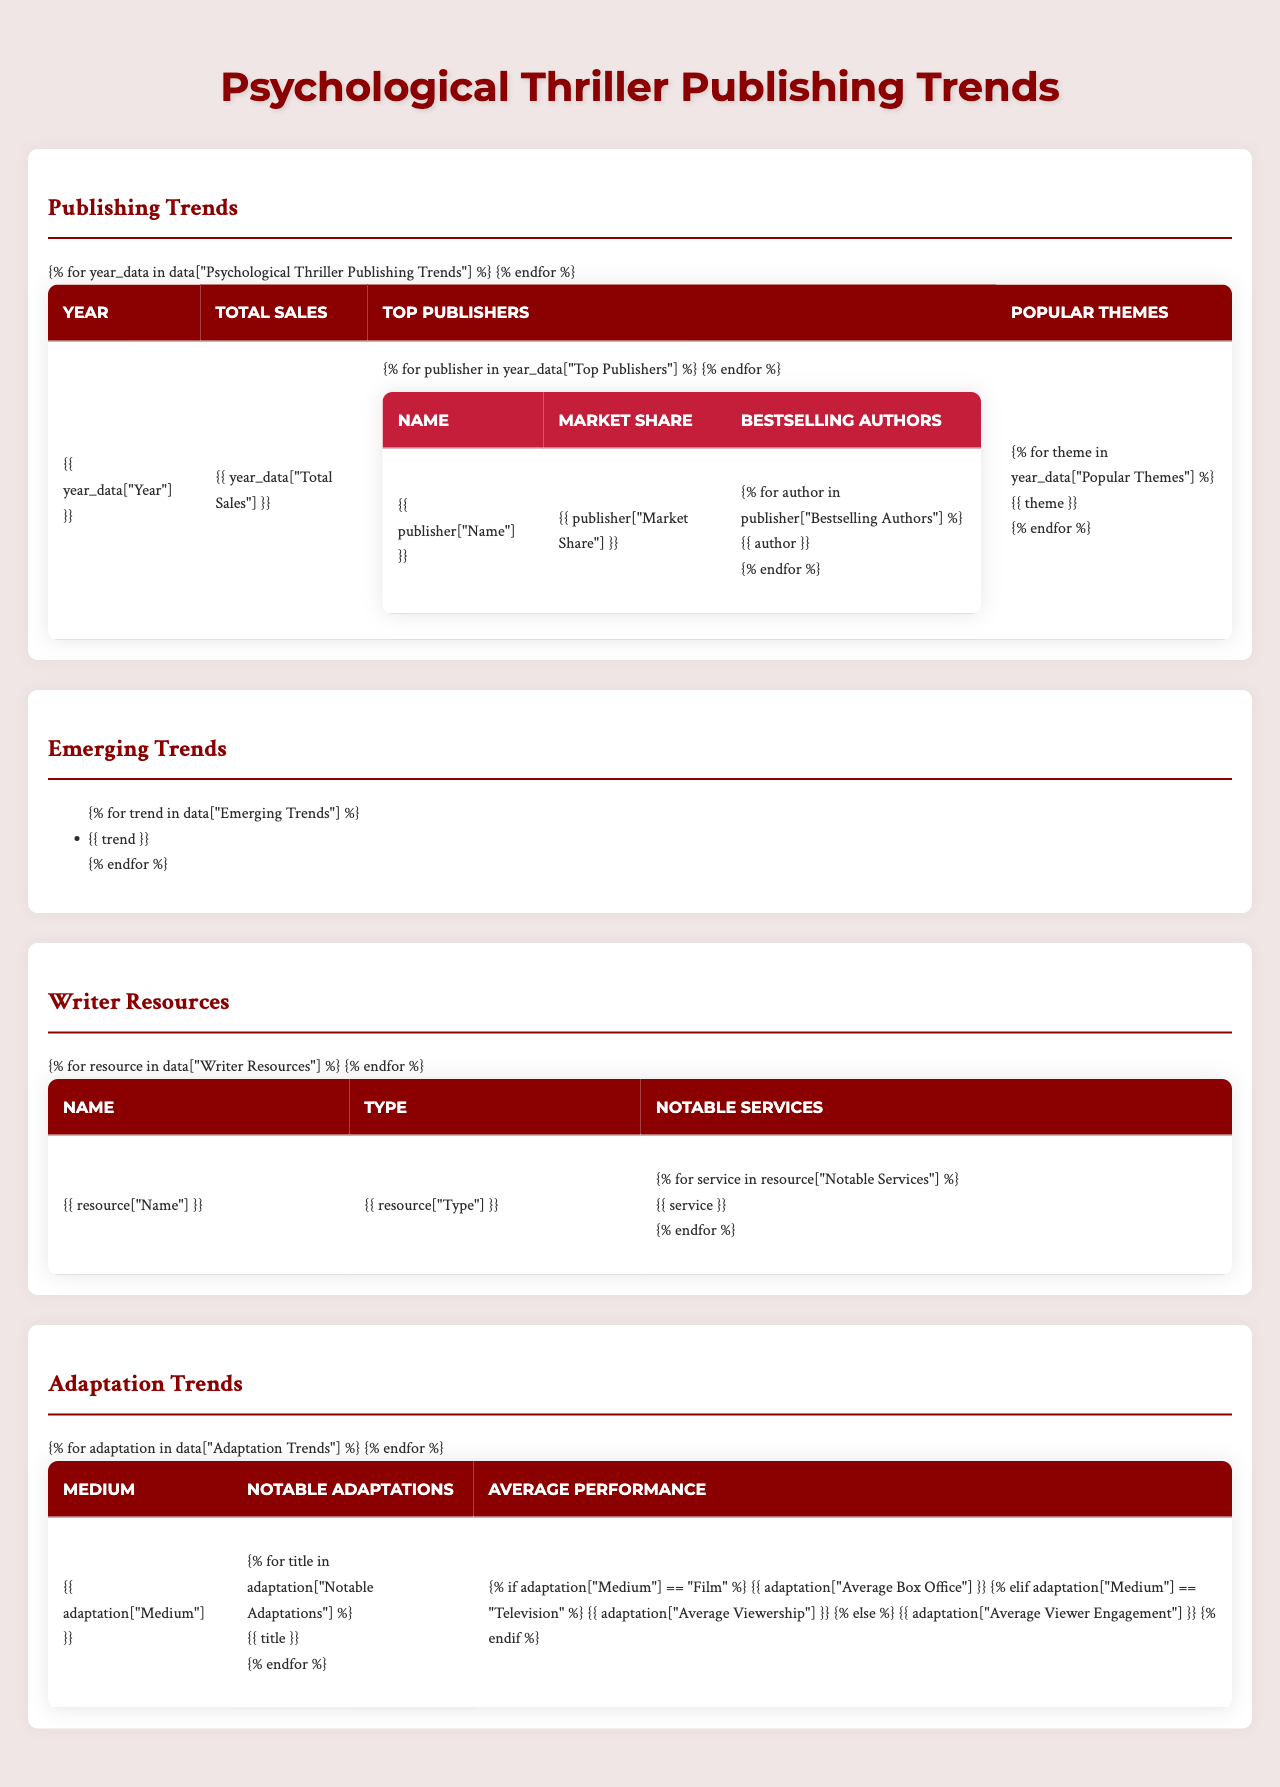What were the total sales of psychological thrillers in 2021? By looking at the table under the "Psychological Thriller Publishing Trends" section, the total sales for the year 2021 is listed as $1.4 billion.
Answer: $1.4B Which publisher had the highest market share in 2020? In the table, the top publishers for 2020 show that Penguin Random House had the highest market share at 22%.
Answer: Penguin Random House What are the popular themes for psychological thrillers in 2022? The "Popular Themes" section for 2022 indicates three popular themes: Pandemic-related Isolation, Social Media Deception, and Generational Trauma.
Answer: Pandemic-related Isolation, Social Media Deception, Generational Trauma How much did total sales increase from 2020 to 2022? To find the increase, subtract the total sales of 2020 ($1.2 billion) from that of 2022 ($1.6 billion). Thus, $1.6 billion - $1.2 billion = $0.4 billion.
Answer: $0.4B Is there a trend indicating publishers are focusing on diverse representation? The "Emerging Trends" section includes "Diverse representation in protagonists and authors," confirming that this is a trend within the publishing industry.
Answer: Yes How many unique bestselling authors are listed for the top three publishers in 2021? The top three publishers for 2021 each have three bestselling authors. Hence, the count is 3 (Hachette) + 3 (Penguin Random House) + 3 (Macmillan) = 9 unique authors.
Answer: 9 Which medium had the highest average box office performance for adaptations? The table states that the average box office for film adaptations is $85 million, which is higher than the viewership for television and completion rate for streaming platforms.
Answer: Film What commonality is observed in popular themes between 2021 and 2022? Both years contain themes relating to psychological elements and societal issues, with 2021 featuring Psychological Manipulation and 2022 highlighting Social Media Deception.
Answer: Psychological elements and societal issues Which publisher consistently appeared in the top three from 2020 to 2022? By examining the "Top Publishers" for each year, it can be noted that Penguin Random House appears in all three years, confirming its consistent presence.
Answer: Penguin Random House What is the total average viewership for notable television adaptations listed? The average viewership per episode for television adaptations is given as 5.2 million. Since there are no other numerical averages given, it remains as such.
Answer: 5.2M per episode 